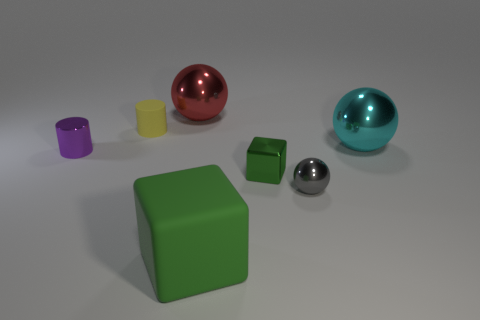Add 1 matte cylinders. How many objects exist? 8 Subtract all big metallic spheres. How many spheres are left? 1 Subtract all purple cylinders. How many cylinders are left? 1 Subtract all gray spheres. Subtract all red cylinders. How many spheres are left? 2 Subtract all blue rubber things. Subtract all small shiny blocks. How many objects are left? 6 Add 4 shiny cubes. How many shiny cubes are left? 5 Add 2 brown rubber things. How many brown rubber things exist? 2 Subtract 0 green cylinders. How many objects are left? 7 Subtract all cylinders. How many objects are left? 5 Subtract 2 cylinders. How many cylinders are left? 0 